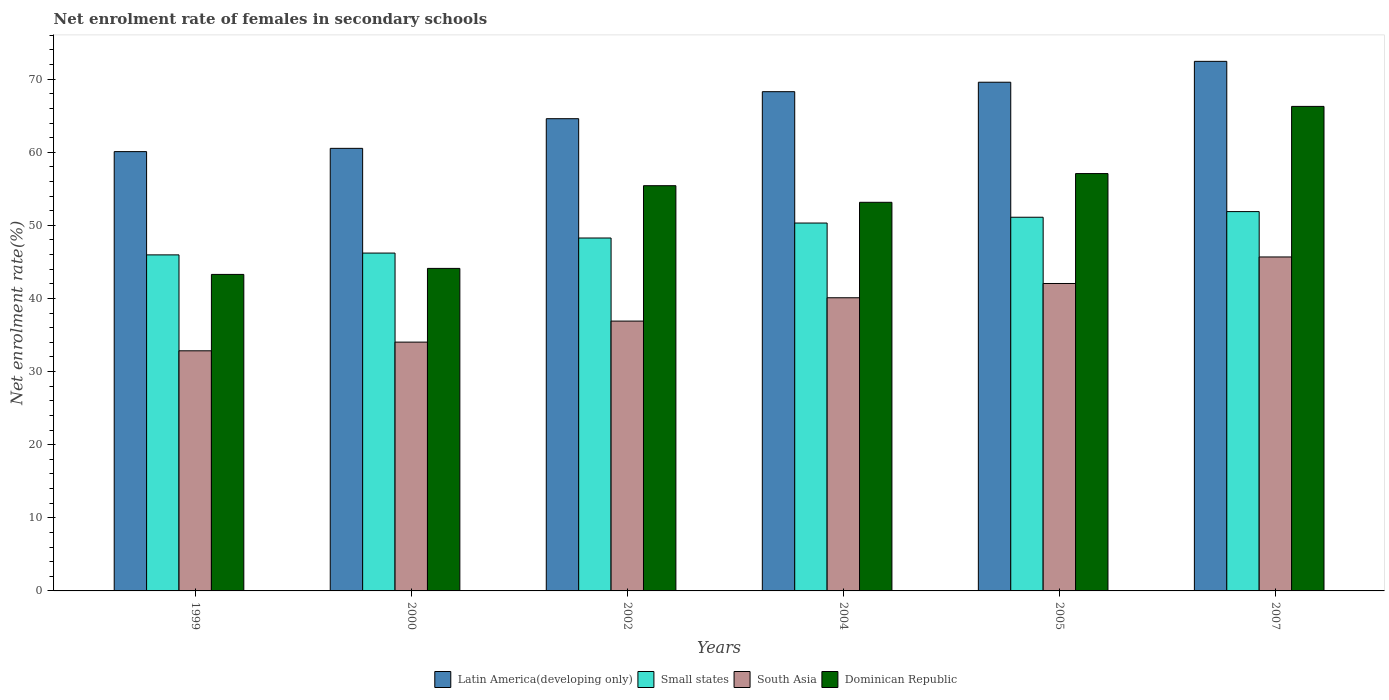Are the number of bars on each tick of the X-axis equal?
Offer a terse response. Yes. How many bars are there on the 2nd tick from the right?
Provide a succinct answer. 4. What is the net enrolment rate of females in secondary schools in Small states in 1999?
Provide a short and direct response. 45.96. Across all years, what is the maximum net enrolment rate of females in secondary schools in Latin America(developing only)?
Your response must be concise. 72.44. Across all years, what is the minimum net enrolment rate of females in secondary schools in Latin America(developing only)?
Offer a very short reply. 60.09. In which year was the net enrolment rate of females in secondary schools in Small states maximum?
Offer a terse response. 2007. What is the total net enrolment rate of females in secondary schools in Small states in the graph?
Offer a very short reply. 293.76. What is the difference between the net enrolment rate of females in secondary schools in Dominican Republic in 2000 and that in 2005?
Your answer should be very brief. -12.97. What is the difference between the net enrolment rate of females in secondary schools in Small states in 2007 and the net enrolment rate of females in secondary schools in South Asia in 2005?
Your answer should be very brief. 9.83. What is the average net enrolment rate of females in secondary schools in Dominican Republic per year?
Your answer should be very brief. 53.23. In the year 2004, what is the difference between the net enrolment rate of females in secondary schools in Dominican Republic and net enrolment rate of females in secondary schools in Latin America(developing only)?
Ensure brevity in your answer.  -15.13. What is the ratio of the net enrolment rate of females in secondary schools in South Asia in 2002 to that in 2005?
Give a very brief answer. 0.88. Is the net enrolment rate of females in secondary schools in Small states in 2004 less than that in 2007?
Ensure brevity in your answer.  Yes. Is the difference between the net enrolment rate of females in secondary schools in Dominican Republic in 1999 and 2004 greater than the difference between the net enrolment rate of females in secondary schools in Latin America(developing only) in 1999 and 2004?
Ensure brevity in your answer.  No. What is the difference between the highest and the second highest net enrolment rate of females in secondary schools in South Asia?
Provide a short and direct response. 3.63. What is the difference between the highest and the lowest net enrolment rate of females in secondary schools in South Asia?
Ensure brevity in your answer.  12.84. In how many years, is the net enrolment rate of females in secondary schools in Small states greater than the average net enrolment rate of females in secondary schools in Small states taken over all years?
Your answer should be compact. 3. Is the sum of the net enrolment rate of females in secondary schools in South Asia in 2002 and 2007 greater than the maximum net enrolment rate of females in secondary schools in Dominican Republic across all years?
Your answer should be very brief. Yes. Is it the case that in every year, the sum of the net enrolment rate of females in secondary schools in Dominican Republic and net enrolment rate of females in secondary schools in South Asia is greater than the sum of net enrolment rate of females in secondary schools in Small states and net enrolment rate of females in secondary schools in Latin America(developing only)?
Your answer should be very brief. No. What does the 4th bar from the left in 1999 represents?
Your answer should be compact. Dominican Republic. What does the 3rd bar from the right in 1999 represents?
Your answer should be compact. Small states. How many bars are there?
Ensure brevity in your answer.  24. Are all the bars in the graph horizontal?
Keep it short and to the point. No. How many years are there in the graph?
Offer a very short reply. 6. Are the values on the major ticks of Y-axis written in scientific E-notation?
Your answer should be compact. No. Does the graph contain any zero values?
Your answer should be very brief. No. Where does the legend appear in the graph?
Your answer should be very brief. Bottom center. How many legend labels are there?
Ensure brevity in your answer.  4. What is the title of the graph?
Your answer should be very brief. Net enrolment rate of females in secondary schools. Does "Slovenia" appear as one of the legend labels in the graph?
Keep it short and to the point. No. What is the label or title of the X-axis?
Offer a very short reply. Years. What is the label or title of the Y-axis?
Ensure brevity in your answer.  Net enrolment rate(%). What is the Net enrolment rate(%) of Latin America(developing only) in 1999?
Offer a very short reply. 60.09. What is the Net enrolment rate(%) of Small states in 1999?
Make the answer very short. 45.96. What is the Net enrolment rate(%) of South Asia in 1999?
Make the answer very short. 32.84. What is the Net enrolment rate(%) of Dominican Republic in 1999?
Your response must be concise. 43.29. What is the Net enrolment rate(%) of Latin America(developing only) in 2000?
Provide a short and direct response. 60.53. What is the Net enrolment rate(%) in Small states in 2000?
Offer a terse response. 46.21. What is the Net enrolment rate(%) in South Asia in 2000?
Keep it short and to the point. 34.03. What is the Net enrolment rate(%) of Dominican Republic in 2000?
Provide a short and direct response. 44.11. What is the Net enrolment rate(%) in Latin America(developing only) in 2002?
Keep it short and to the point. 64.59. What is the Net enrolment rate(%) of Small states in 2002?
Keep it short and to the point. 48.27. What is the Net enrolment rate(%) of South Asia in 2002?
Keep it short and to the point. 36.91. What is the Net enrolment rate(%) in Dominican Republic in 2002?
Offer a terse response. 55.43. What is the Net enrolment rate(%) in Latin America(developing only) in 2004?
Your answer should be very brief. 68.29. What is the Net enrolment rate(%) of Small states in 2004?
Ensure brevity in your answer.  50.32. What is the Net enrolment rate(%) in South Asia in 2004?
Ensure brevity in your answer.  40.1. What is the Net enrolment rate(%) of Dominican Republic in 2004?
Your response must be concise. 53.16. What is the Net enrolment rate(%) in Latin America(developing only) in 2005?
Make the answer very short. 69.58. What is the Net enrolment rate(%) of Small states in 2005?
Keep it short and to the point. 51.11. What is the Net enrolment rate(%) in South Asia in 2005?
Make the answer very short. 42.05. What is the Net enrolment rate(%) in Dominican Republic in 2005?
Your response must be concise. 57.09. What is the Net enrolment rate(%) of Latin America(developing only) in 2007?
Provide a short and direct response. 72.44. What is the Net enrolment rate(%) in Small states in 2007?
Your response must be concise. 51.88. What is the Net enrolment rate(%) of South Asia in 2007?
Your answer should be very brief. 45.68. What is the Net enrolment rate(%) in Dominican Republic in 2007?
Offer a terse response. 66.27. Across all years, what is the maximum Net enrolment rate(%) of Latin America(developing only)?
Provide a succinct answer. 72.44. Across all years, what is the maximum Net enrolment rate(%) in Small states?
Ensure brevity in your answer.  51.88. Across all years, what is the maximum Net enrolment rate(%) in South Asia?
Ensure brevity in your answer.  45.68. Across all years, what is the maximum Net enrolment rate(%) of Dominican Republic?
Give a very brief answer. 66.27. Across all years, what is the minimum Net enrolment rate(%) of Latin America(developing only)?
Your answer should be compact. 60.09. Across all years, what is the minimum Net enrolment rate(%) in Small states?
Provide a succinct answer. 45.96. Across all years, what is the minimum Net enrolment rate(%) in South Asia?
Ensure brevity in your answer.  32.84. Across all years, what is the minimum Net enrolment rate(%) of Dominican Republic?
Ensure brevity in your answer.  43.29. What is the total Net enrolment rate(%) of Latin America(developing only) in the graph?
Provide a succinct answer. 395.52. What is the total Net enrolment rate(%) of Small states in the graph?
Keep it short and to the point. 293.76. What is the total Net enrolment rate(%) in South Asia in the graph?
Keep it short and to the point. 231.61. What is the total Net enrolment rate(%) in Dominican Republic in the graph?
Your answer should be compact. 319.35. What is the difference between the Net enrolment rate(%) in Latin America(developing only) in 1999 and that in 2000?
Ensure brevity in your answer.  -0.45. What is the difference between the Net enrolment rate(%) of Small states in 1999 and that in 2000?
Provide a succinct answer. -0.25. What is the difference between the Net enrolment rate(%) of South Asia in 1999 and that in 2000?
Provide a succinct answer. -1.19. What is the difference between the Net enrolment rate(%) in Dominican Republic in 1999 and that in 2000?
Ensure brevity in your answer.  -0.82. What is the difference between the Net enrolment rate(%) in Latin America(developing only) in 1999 and that in 2002?
Make the answer very short. -4.5. What is the difference between the Net enrolment rate(%) of Small states in 1999 and that in 2002?
Your answer should be compact. -2.31. What is the difference between the Net enrolment rate(%) of South Asia in 1999 and that in 2002?
Ensure brevity in your answer.  -4.06. What is the difference between the Net enrolment rate(%) of Dominican Republic in 1999 and that in 2002?
Provide a short and direct response. -12.13. What is the difference between the Net enrolment rate(%) in Latin America(developing only) in 1999 and that in 2004?
Keep it short and to the point. -8.2. What is the difference between the Net enrolment rate(%) in Small states in 1999 and that in 2004?
Provide a short and direct response. -4.35. What is the difference between the Net enrolment rate(%) in South Asia in 1999 and that in 2004?
Your answer should be compact. -7.26. What is the difference between the Net enrolment rate(%) of Dominican Republic in 1999 and that in 2004?
Provide a short and direct response. -9.86. What is the difference between the Net enrolment rate(%) of Latin America(developing only) in 1999 and that in 2005?
Make the answer very short. -9.49. What is the difference between the Net enrolment rate(%) in Small states in 1999 and that in 2005?
Provide a short and direct response. -5.15. What is the difference between the Net enrolment rate(%) in South Asia in 1999 and that in 2005?
Your answer should be very brief. -9.21. What is the difference between the Net enrolment rate(%) of Dominican Republic in 1999 and that in 2005?
Your response must be concise. -13.79. What is the difference between the Net enrolment rate(%) of Latin America(developing only) in 1999 and that in 2007?
Your response must be concise. -12.35. What is the difference between the Net enrolment rate(%) in Small states in 1999 and that in 2007?
Make the answer very short. -5.92. What is the difference between the Net enrolment rate(%) of South Asia in 1999 and that in 2007?
Provide a short and direct response. -12.84. What is the difference between the Net enrolment rate(%) in Dominican Republic in 1999 and that in 2007?
Your answer should be very brief. -22.98. What is the difference between the Net enrolment rate(%) of Latin America(developing only) in 2000 and that in 2002?
Ensure brevity in your answer.  -4.06. What is the difference between the Net enrolment rate(%) of Small states in 2000 and that in 2002?
Your answer should be compact. -2.06. What is the difference between the Net enrolment rate(%) of South Asia in 2000 and that in 2002?
Your answer should be very brief. -2.88. What is the difference between the Net enrolment rate(%) of Dominican Republic in 2000 and that in 2002?
Give a very brief answer. -11.31. What is the difference between the Net enrolment rate(%) in Latin America(developing only) in 2000 and that in 2004?
Provide a succinct answer. -7.75. What is the difference between the Net enrolment rate(%) in Small states in 2000 and that in 2004?
Provide a short and direct response. -4.11. What is the difference between the Net enrolment rate(%) in South Asia in 2000 and that in 2004?
Give a very brief answer. -6.07. What is the difference between the Net enrolment rate(%) in Dominican Republic in 2000 and that in 2004?
Your response must be concise. -9.04. What is the difference between the Net enrolment rate(%) of Latin America(developing only) in 2000 and that in 2005?
Ensure brevity in your answer.  -9.05. What is the difference between the Net enrolment rate(%) of South Asia in 2000 and that in 2005?
Your answer should be compact. -8.02. What is the difference between the Net enrolment rate(%) of Dominican Republic in 2000 and that in 2005?
Your answer should be very brief. -12.97. What is the difference between the Net enrolment rate(%) of Latin America(developing only) in 2000 and that in 2007?
Ensure brevity in your answer.  -11.9. What is the difference between the Net enrolment rate(%) in Small states in 2000 and that in 2007?
Make the answer very short. -5.67. What is the difference between the Net enrolment rate(%) of South Asia in 2000 and that in 2007?
Provide a succinct answer. -11.65. What is the difference between the Net enrolment rate(%) of Dominican Republic in 2000 and that in 2007?
Keep it short and to the point. -22.16. What is the difference between the Net enrolment rate(%) of Latin America(developing only) in 2002 and that in 2004?
Provide a succinct answer. -3.7. What is the difference between the Net enrolment rate(%) of Small states in 2002 and that in 2004?
Provide a succinct answer. -2.05. What is the difference between the Net enrolment rate(%) in South Asia in 2002 and that in 2004?
Your answer should be very brief. -3.19. What is the difference between the Net enrolment rate(%) in Dominican Republic in 2002 and that in 2004?
Ensure brevity in your answer.  2.27. What is the difference between the Net enrolment rate(%) in Latin America(developing only) in 2002 and that in 2005?
Offer a very short reply. -4.99. What is the difference between the Net enrolment rate(%) in Small states in 2002 and that in 2005?
Your response must be concise. -2.84. What is the difference between the Net enrolment rate(%) in South Asia in 2002 and that in 2005?
Give a very brief answer. -5.14. What is the difference between the Net enrolment rate(%) in Dominican Republic in 2002 and that in 2005?
Your answer should be very brief. -1.66. What is the difference between the Net enrolment rate(%) of Latin America(developing only) in 2002 and that in 2007?
Ensure brevity in your answer.  -7.84. What is the difference between the Net enrolment rate(%) in Small states in 2002 and that in 2007?
Offer a terse response. -3.61. What is the difference between the Net enrolment rate(%) in South Asia in 2002 and that in 2007?
Your answer should be compact. -8.77. What is the difference between the Net enrolment rate(%) in Dominican Republic in 2002 and that in 2007?
Keep it short and to the point. -10.85. What is the difference between the Net enrolment rate(%) of Latin America(developing only) in 2004 and that in 2005?
Your answer should be very brief. -1.29. What is the difference between the Net enrolment rate(%) in Small states in 2004 and that in 2005?
Keep it short and to the point. -0.79. What is the difference between the Net enrolment rate(%) in South Asia in 2004 and that in 2005?
Ensure brevity in your answer.  -1.95. What is the difference between the Net enrolment rate(%) of Dominican Republic in 2004 and that in 2005?
Make the answer very short. -3.93. What is the difference between the Net enrolment rate(%) of Latin America(developing only) in 2004 and that in 2007?
Provide a succinct answer. -4.15. What is the difference between the Net enrolment rate(%) of Small states in 2004 and that in 2007?
Keep it short and to the point. -1.56. What is the difference between the Net enrolment rate(%) of South Asia in 2004 and that in 2007?
Offer a terse response. -5.58. What is the difference between the Net enrolment rate(%) in Dominican Republic in 2004 and that in 2007?
Ensure brevity in your answer.  -13.12. What is the difference between the Net enrolment rate(%) of Latin America(developing only) in 2005 and that in 2007?
Offer a very short reply. -2.85. What is the difference between the Net enrolment rate(%) in Small states in 2005 and that in 2007?
Provide a succinct answer. -0.77. What is the difference between the Net enrolment rate(%) of South Asia in 2005 and that in 2007?
Offer a terse response. -3.63. What is the difference between the Net enrolment rate(%) in Dominican Republic in 2005 and that in 2007?
Make the answer very short. -9.19. What is the difference between the Net enrolment rate(%) in Latin America(developing only) in 1999 and the Net enrolment rate(%) in Small states in 2000?
Your response must be concise. 13.88. What is the difference between the Net enrolment rate(%) of Latin America(developing only) in 1999 and the Net enrolment rate(%) of South Asia in 2000?
Your response must be concise. 26.06. What is the difference between the Net enrolment rate(%) in Latin America(developing only) in 1999 and the Net enrolment rate(%) in Dominican Republic in 2000?
Provide a short and direct response. 15.97. What is the difference between the Net enrolment rate(%) in Small states in 1999 and the Net enrolment rate(%) in South Asia in 2000?
Give a very brief answer. 11.93. What is the difference between the Net enrolment rate(%) in Small states in 1999 and the Net enrolment rate(%) in Dominican Republic in 2000?
Your response must be concise. 1.85. What is the difference between the Net enrolment rate(%) of South Asia in 1999 and the Net enrolment rate(%) of Dominican Republic in 2000?
Make the answer very short. -11.27. What is the difference between the Net enrolment rate(%) of Latin America(developing only) in 1999 and the Net enrolment rate(%) of Small states in 2002?
Give a very brief answer. 11.82. What is the difference between the Net enrolment rate(%) of Latin America(developing only) in 1999 and the Net enrolment rate(%) of South Asia in 2002?
Your response must be concise. 23.18. What is the difference between the Net enrolment rate(%) in Latin America(developing only) in 1999 and the Net enrolment rate(%) in Dominican Republic in 2002?
Your answer should be compact. 4.66. What is the difference between the Net enrolment rate(%) of Small states in 1999 and the Net enrolment rate(%) of South Asia in 2002?
Make the answer very short. 9.06. What is the difference between the Net enrolment rate(%) of Small states in 1999 and the Net enrolment rate(%) of Dominican Republic in 2002?
Provide a succinct answer. -9.46. What is the difference between the Net enrolment rate(%) of South Asia in 1999 and the Net enrolment rate(%) of Dominican Republic in 2002?
Make the answer very short. -22.58. What is the difference between the Net enrolment rate(%) of Latin America(developing only) in 1999 and the Net enrolment rate(%) of Small states in 2004?
Keep it short and to the point. 9.77. What is the difference between the Net enrolment rate(%) in Latin America(developing only) in 1999 and the Net enrolment rate(%) in South Asia in 2004?
Offer a terse response. 19.99. What is the difference between the Net enrolment rate(%) of Latin America(developing only) in 1999 and the Net enrolment rate(%) of Dominican Republic in 2004?
Give a very brief answer. 6.93. What is the difference between the Net enrolment rate(%) in Small states in 1999 and the Net enrolment rate(%) in South Asia in 2004?
Ensure brevity in your answer.  5.87. What is the difference between the Net enrolment rate(%) in Small states in 1999 and the Net enrolment rate(%) in Dominican Republic in 2004?
Ensure brevity in your answer.  -7.19. What is the difference between the Net enrolment rate(%) of South Asia in 1999 and the Net enrolment rate(%) of Dominican Republic in 2004?
Give a very brief answer. -20.31. What is the difference between the Net enrolment rate(%) in Latin America(developing only) in 1999 and the Net enrolment rate(%) in Small states in 2005?
Make the answer very short. 8.98. What is the difference between the Net enrolment rate(%) in Latin America(developing only) in 1999 and the Net enrolment rate(%) in South Asia in 2005?
Your answer should be very brief. 18.04. What is the difference between the Net enrolment rate(%) in Latin America(developing only) in 1999 and the Net enrolment rate(%) in Dominican Republic in 2005?
Ensure brevity in your answer.  3. What is the difference between the Net enrolment rate(%) in Small states in 1999 and the Net enrolment rate(%) in South Asia in 2005?
Offer a very short reply. 3.91. What is the difference between the Net enrolment rate(%) in Small states in 1999 and the Net enrolment rate(%) in Dominican Republic in 2005?
Ensure brevity in your answer.  -11.12. What is the difference between the Net enrolment rate(%) of South Asia in 1999 and the Net enrolment rate(%) of Dominican Republic in 2005?
Provide a succinct answer. -24.24. What is the difference between the Net enrolment rate(%) of Latin America(developing only) in 1999 and the Net enrolment rate(%) of Small states in 2007?
Provide a short and direct response. 8.2. What is the difference between the Net enrolment rate(%) of Latin America(developing only) in 1999 and the Net enrolment rate(%) of South Asia in 2007?
Offer a very short reply. 14.41. What is the difference between the Net enrolment rate(%) of Latin America(developing only) in 1999 and the Net enrolment rate(%) of Dominican Republic in 2007?
Keep it short and to the point. -6.19. What is the difference between the Net enrolment rate(%) in Small states in 1999 and the Net enrolment rate(%) in South Asia in 2007?
Your response must be concise. 0.28. What is the difference between the Net enrolment rate(%) in Small states in 1999 and the Net enrolment rate(%) in Dominican Republic in 2007?
Make the answer very short. -20.31. What is the difference between the Net enrolment rate(%) in South Asia in 1999 and the Net enrolment rate(%) in Dominican Republic in 2007?
Offer a terse response. -33.43. What is the difference between the Net enrolment rate(%) in Latin America(developing only) in 2000 and the Net enrolment rate(%) in Small states in 2002?
Your response must be concise. 12.26. What is the difference between the Net enrolment rate(%) of Latin America(developing only) in 2000 and the Net enrolment rate(%) of South Asia in 2002?
Make the answer very short. 23.63. What is the difference between the Net enrolment rate(%) of Latin America(developing only) in 2000 and the Net enrolment rate(%) of Dominican Republic in 2002?
Provide a short and direct response. 5.11. What is the difference between the Net enrolment rate(%) in Small states in 2000 and the Net enrolment rate(%) in South Asia in 2002?
Give a very brief answer. 9.3. What is the difference between the Net enrolment rate(%) of Small states in 2000 and the Net enrolment rate(%) of Dominican Republic in 2002?
Offer a very short reply. -9.22. What is the difference between the Net enrolment rate(%) in South Asia in 2000 and the Net enrolment rate(%) in Dominican Republic in 2002?
Provide a succinct answer. -21.39. What is the difference between the Net enrolment rate(%) of Latin America(developing only) in 2000 and the Net enrolment rate(%) of Small states in 2004?
Make the answer very short. 10.22. What is the difference between the Net enrolment rate(%) of Latin America(developing only) in 2000 and the Net enrolment rate(%) of South Asia in 2004?
Offer a terse response. 20.44. What is the difference between the Net enrolment rate(%) in Latin America(developing only) in 2000 and the Net enrolment rate(%) in Dominican Republic in 2004?
Ensure brevity in your answer.  7.38. What is the difference between the Net enrolment rate(%) of Small states in 2000 and the Net enrolment rate(%) of South Asia in 2004?
Provide a succinct answer. 6.11. What is the difference between the Net enrolment rate(%) in Small states in 2000 and the Net enrolment rate(%) in Dominican Republic in 2004?
Provide a short and direct response. -6.94. What is the difference between the Net enrolment rate(%) in South Asia in 2000 and the Net enrolment rate(%) in Dominican Republic in 2004?
Your response must be concise. -19.12. What is the difference between the Net enrolment rate(%) of Latin America(developing only) in 2000 and the Net enrolment rate(%) of Small states in 2005?
Offer a very short reply. 9.42. What is the difference between the Net enrolment rate(%) of Latin America(developing only) in 2000 and the Net enrolment rate(%) of South Asia in 2005?
Provide a short and direct response. 18.48. What is the difference between the Net enrolment rate(%) in Latin America(developing only) in 2000 and the Net enrolment rate(%) in Dominican Republic in 2005?
Your answer should be compact. 3.45. What is the difference between the Net enrolment rate(%) of Small states in 2000 and the Net enrolment rate(%) of South Asia in 2005?
Ensure brevity in your answer.  4.16. What is the difference between the Net enrolment rate(%) in Small states in 2000 and the Net enrolment rate(%) in Dominican Republic in 2005?
Provide a short and direct response. -10.88. What is the difference between the Net enrolment rate(%) of South Asia in 2000 and the Net enrolment rate(%) of Dominican Republic in 2005?
Provide a succinct answer. -23.05. What is the difference between the Net enrolment rate(%) of Latin America(developing only) in 2000 and the Net enrolment rate(%) of Small states in 2007?
Give a very brief answer. 8.65. What is the difference between the Net enrolment rate(%) in Latin America(developing only) in 2000 and the Net enrolment rate(%) in South Asia in 2007?
Provide a short and direct response. 14.85. What is the difference between the Net enrolment rate(%) of Latin America(developing only) in 2000 and the Net enrolment rate(%) of Dominican Republic in 2007?
Give a very brief answer. -5.74. What is the difference between the Net enrolment rate(%) of Small states in 2000 and the Net enrolment rate(%) of South Asia in 2007?
Offer a terse response. 0.53. What is the difference between the Net enrolment rate(%) of Small states in 2000 and the Net enrolment rate(%) of Dominican Republic in 2007?
Make the answer very short. -20.06. What is the difference between the Net enrolment rate(%) of South Asia in 2000 and the Net enrolment rate(%) of Dominican Republic in 2007?
Give a very brief answer. -32.24. What is the difference between the Net enrolment rate(%) of Latin America(developing only) in 2002 and the Net enrolment rate(%) of Small states in 2004?
Make the answer very short. 14.27. What is the difference between the Net enrolment rate(%) of Latin America(developing only) in 2002 and the Net enrolment rate(%) of South Asia in 2004?
Make the answer very short. 24.49. What is the difference between the Net enrolment rate(%) of Latin America(developing only) in 2002 and the Net enrolment rate(%) of Dominican Republic in 2004?
Provide a short and direct response. 11.43. What is the difference between the Net enrolment rate(%) of Small states in 2002 and the Net enrolment rate(%) of South Asia in 2004?
Provide a succinct answer. 8.17. What is the difference between the Net enrolment rate(%) in Small states in 2002 and the Net enrolment rate(%) in Dominican Republic in 2004?
Provide a short and direct response. -4.89. What is the difference between the Net enrolment rate(%) of South Asia in 2002 and the Net enrolment rate(%) of Dominican Republic in 2004?
Keep it short and to the point. -16.25. What is the difference between the Net enrolment rate(%) of Latin America(developing only) in 2002 and the Net enrolment rate(%) of Small states in 2005?
Offer a very short reply. 13.48. What is the difference between the Net enrolment rate(%) in Latin America(developing only) in 2002 and the Net enrolment rate(%) in South Asia in 2005?
Your answer should be very brief. 22.54. What is the difference between the Net enrolment rate(%) in Latin America(developing only) in 2002 and the Net enrolment rate(%) in Dominican Republic in 2005?
Make the answer very short. 7.5. What is the difference between the Net enrolment rate(%) of Small states in 2002 and the Net enrolment rate(%) of South Asia in 2005?
Your answer should be compact. 6.22. What is the difference between the Net enrolment rate(%) in Small states in 2002 and the Net enrolment rate(%) in Dominican Republic in 2005?
Your response must be concise. -8.82. What is the difference between the Net enrolment rate(%) of South Asia in 2002 and the Net enrolment rate(%) of Dominican Republic in 2005?
Your answer should be compact. -20.18. What is the difference between the Net enrolment rate(%) in Latin America(developing only) in 2002 and the Net enrolment rate(%) in Small states in 2007?
Provide a succinct answer. 12.71. What is the difference between the Net enrolment rate(%) of Latin America(developing only) in 2002 and the Net enrolment rate(%) of South Asia in 2007?
Offer a terse response. 18.91. What is the difference between the Net enrolment rate(%) in Latin America(developing only) in 2002 and the Net enrolment rate(%) in Dominican Republic in 2007?
Your response must be concise. -1.68. What is the difference between the Net enrolment rate(%) of Small states in 2002 and the Net enrolment rate(%) of South Asia in 2007?
Make the answer very short. 2.59. What is the difference between the Net enrolment rate(%) in Small states in 2002 and the Net enrolment rate(%) in Dominican Republic in 2007?
Ensure brevity in your answer.  -18. What is the difference between the Net enrolment rate(%) in South Asia in 2002 and the Net enrolment rate(%) in Dominican Republic in 2007?
Make the answer very short. -29.37. What is the difference between the Net enrolment rate(%) of Latin America(developing only) in 2004 and the Net enrolment rate(%) of Small states in 2005?
Your response must be concise. 17.18. What is the difference between the Net enrolment rate(%) in Latin America(developing only) in 2004 and the Net enrolment rate(%) in South Asia in 2005?
Your response must be concise. 26.24. What is the difference between the Net enrolment rate(%) in Latin America(developing only) in 2004 and the Net enrolment rate(%) in Dominican Republic in 2005?
Your answer should be very brief. 11.2. What is the difference between the Net enrolment rate(%) in Small states in 2004 and the Net enrolment rate(%) in South Asia in 2005?
Make the answer very short. 8.27. What is the difference between the Net enrolment rate(%) in Small states in 2004 and the Net enrolment rate(%) in Dominican Republic in 2005?
Provide a succinct answer. -6.77. What is the difference between the Net enrolment rate(%) of South Asia in 2004 and the Net enrolment rate(%) of Dominican Republic in 2005?
Keep it short and to the point. -16.99. What is the difference between the Net enrolment rate(%) in Latin America(developing only) in 2004 and the Net enrolment rate(%) in Small states in 2007?
Provide a succinct answer. 16.4. What is the difference between the Net enrolment rate(%) of Latin America(developing only) in 2004 and the Net enrolment rate(%) of South Asia in 2007?
Your answer should be very brief. 22.61. What is the difference between the Net enrolment rate(%) of Latin America(developing only) in 2004 and the Net enrolment rate(%) of Dominican Republic in 2007?
Your response must be concise. 2.01. What is the difference between the Net enrolment rate(%) in Small states in 2004 and the Net enrolment rate(%) in South Asia in 2007?
Provide a succinct answer. 4.64. What is the difference between the Net enrolment rate(%) of Small states in 2004 and the Net enrolment rate(%) of Dominican Republic in 2007?
Offer a terse response. -15.96. What is the difference between the Net enrolment rate(%) of South Asia in 2004 and the Net enrolment rate(%) of Dominican Republic in 2007?
Offer a terse response. -26.18. What is the difference between the Net enrolment rate(%) of Latin America(developing only) in 2005 and the Net enrolment rate(%) of Small states in 2007?
Provide a short and direct response. 17.7. What is the difference between the Net enrolment rate(%) in Latin America(developing only) in 2005 and the Net enrolment rate(%) in South Asia in 2007?
Your response must be concise. 23.9. What is the difference between the Net enrolment rate(%) in Latin America(developing only) in 2005 and the Net enrolment rate(%) in Dominican Republic in 2007?
Give a very brief answer. 3.31. What is the difference between the Net enrolment rate(%) of Small states in 2005 and the Net enrolment rate(%) of South Asia in 2007?
Your response must be concise. 5.43. What is the difference between the Net enrolment rate(%) of Small states in 2005 and the Net enrolment rate(%) of Dominican Republic in 2007?
Make the answer very short. -15.16. What is the difference between the Net enrolment rate(%) in South Asia in 2005 and the Net enrolment rate(%) in Dominican Republic in 2007?
Offer a very short reply. -24.22. What is the average Net enrolment rate(%) in Latin America(developing only) per year?
Your answer should be very brief. 65.92. What is the average Net enrolment rate(%) of Small states per year?
Your answer should be very brief. 48.96. What is the average Net enrolment rate(%) of South Asia per year?
Ensure brevity in your answer.  38.6. What is the average Net enrolment rate(%) in Dominican Republic per year?
Provide a succinct answer. 53.23. In the year 1999, what is the difference between the Net enrolment rate(%) of Latin America(developing only) and Net enrolment rate(%) of Small states?
Your answer should be very brief. 14.12. In the year 1999, what is the difference between the Net enrolment rate(%) in Latin America(developing only) and Net enrolment rate(%) in South Asia?
Your answer should be compact. 27.24. In the year 1999, what is the difference between the Net enrolment rate(%) in Latin America(developing only) and Net enrolment rate(%) in Dominican Republic?
Your answer should be very brief. 16.8. In the year 1999, what is the difference between the Net enrolment rate(%) of Small states and Net enrolment rate(%) of South Asia?
Keep it short and to the point. 13.12. In the year 1999, what is the difference between the Net enrolment rate(%) in Small states and Net enrolment rate(%) in Dominican Republic?
Offer a terse response. 2.67. In the year 1999, what is the difference between the Net enrolment rate(%) of South Asia and Net enrolment rate(%) of Dominican Republic?
Keep it short and to the point. -10.45. In the year 2000, what is the difference between the Net enrolment rate(%) in Latin America(developing only) and Net enrolment rate(%) in Small states?
Provide a short and direct response. 14.32. In the year 2000, what is the difference between the Net enrolment rate(%) in Latin America(developing only) and Net enrolment rate(%) in South Asia?
Give a very brief answer. 26.5. In the year 2000, what is the difference between the Net enrolment rate(%) in Latin America(developing only) and Net enrolment rate(%) in Dominican Republic?
Give a very brief answer. 16.42. In the year 2000, what is the difference between the Net enrolment rate(%) in Small states and Net enrolment rate(%) in South Asia?
Provide a short and direct response. 12.18. In the year 2000, what is the difference between the Net enrolment rate(%) in Small states and Net enrolment rate(%) in Dominican Republic?
Offer a terse response. 2.1. In the year 2000, what is the difference between the Net enrolment rate(%) of South Asia and Net enrolment rate(%) of Dominican Republic?
Make the answer very short. -10.08. In the year 2002, what is the difference between the Net enrolment rate(%) of Latin America(developing only) and Net enrolment rate(%) of Small states?
Make the answer very short. 16.32. In the year 2002, what is the difference between the Net enrolment rate(%) in Latin America(developing only) and Net enrolment rate(%) in South Asia?
Provide a short and direct response. 27.68. In the year 2002, what is the difference between the Net enrolment rate(%) in Latin America(developing only) and Net enrolment rate(%) in Dominican Republic?
Give a very brief answer. 9.16. In the year 2002, what is the difference between the Net enrolment rate(%) of Small states and Net enrolment rate(%) of South Asia?
Provide a short and direct response. 11.36. In the year 2002, what is the difference between the Net enrolment rate(%) of Small states and Net enrolment rate(%) of Dominican Republic?
Keep it short and to the point. -7.16. In the year 2002, what is the difference between the Net enrolment rate(%) in South Asia and Net enrolment rate(%) in Dominican Republic?
Offer a very short reply. -18.52. In the year 2004, what is the difference between the Net enrolment rate(%) of Latin America(developing only) and Net enrolment rate(%) of Small states?
Ensure brevity in your answer.  17.97. In the year 2004, what is the difference between the Net enrolment rate(%) of Latin America(developing only) and Net enrolment rate(%) of South Asia?
Your response must be concise. 28.19. In the year 2004, what is the difference between the Net enrolment rate(%) in Latin America(developing only) and Net enrolment rate(%) in Dominican Republic?
Your answer should be very brief. 15.13. In the year 2004, what is the difference between the Net enrolment rate(%) of Small states and Net enrolment rate(%) of South Asia?
Your response must be concise. 10.22. In the year 2004, what is the difference between the Net enrolment rate(%) of Small states and Net enrolment rate(%) of Dominican Republic?
Your answer should be compact. -2.84. In the year 2004, what is the difference between the Net enrolment rate(%) of South Asia and Net enrolment rate(%) of Dominican Republic?
Your response must be concise. -13.06. In the year 2005, what is the difference between the Net enrolment rate(%) in Latin America(developing only) and Net enrolment rate(%) in Small states?
Give a very brief answer. 18.47. In the year 2005, what is the difference between the Net enrolment rate(%) of Latin America(developing only) and Net enrolment rate(%) of South Asia?
Your answer should be very brief. 27.53. In the year 2005, what is the difference between the Net enrolment rate(%) in Latin America(developing only) and Net enrolment rate(%) in Dominican Republic?
Make the answer very short. 12.49. In the year 2005, what is the difference between the Net enrolment rate(%) in Small states and Net enrolment rate(%) in South Asia?
Keep it short and to the point. 9.06. In the year 2005, what is the difference between the Net enrolment rate(%) of Small states and Net enrolment rate(%) of Dominican Republic?
Your response must be concise. -5.98. In the year 2005, what is the difference between the Net enrolment rate(%) of South Asia and Net enrolment rate(%) of Dominican Republic?
Provide a short and direct response. -15.04. In the year 2007, what is the difference between the Net enrolment rate(%) of Latin America(developing only) and Net enrolment rate(%) of Small states?
Your answer should be very brief. 20.55. In the year 2007, what is the difference between the Net enrolment rate(%) in Latin America(developing only) and Net enrolment rate(%) in South Asia?
Provide a short and direct response. 26.76. In the year 2007, what is the difference between the Net enrolment rate(%) in Latin America(developing only) and Net enrolment rate(%) in Dominican Republic?
Make the answer very short. 6.16. In the year 2007, what is the difference between the Net enrolment rate(%) of Small states and Net enrolment rate(%) of South Asia?
Your response must be concise. 6.2. In the year 2007, what is the difference between the Net enrolment rate(%) of Small states and Net enrolment rate(%) of Dominican Republic?
Offer a very short reply. -14.39. In the year 2007, what is the difference between the Net enrolment rate(%) in South Asia and Net enrolment rate(%) in Dominican Republic?
Your answer should be compact. -20.59. What is the ratio of the Net enrolment rate(%) in Latin America(developing only) in 1999 to that in 2000?
Provide a succinct answer. 0.99. What is the ratio of the Net enrolment rate(%) in South Asia in 1999 to that in 2000?
Provide a succinct answer. 0.97. What is the ratio of the Net enrolment rate(%) of Dominican Republic in 1999 to that in 2000?
Offer a terse response. 0.98. What is the ratio of the Net enrolment rate(%) in Latin America(developing only) in 1999 to that in 2002?
Offer a terse response. 0.93. What is the ratio of the Net enrolment rate(%) in Small states in 1999 to that in 2002?
Keep it short and to the point. 0.95. What is the ratio of the Net enrolment rate(%) of South Asia in 1999 to that in 2002?
Offer a very short reply. 0.89. What is the ratio of the Net enrolment rate(%) of Dominican Republic in 1999 to that in 2002?
Your answer should be very brief. 0.78. What is the ratio of the Net enrolment rate(%) in Latin America(developing only) in 1999 to that in 2004?
Your response must be concise. 0.88. What is the ratio of the Net enrolment rate(%) of Small states in 1999 to that in 2004?
Your answer should be compact. 0.91. What is the ratio of the Net enrolment rate(%) in South Asia in 1999 to that in 2004?
Provide a short and direct response. 0.82. What is the ratio of the Net enrolment rate(%) of Dominican Republic in 1999 to that in 2004?
Ensure brevity in your answer.  0.81. What is the ratio of the Net enrolment rate(%) in Latin America(developing only) in 1999 to that in 2005?
Provide a short and direct response. 0.86. What is the ratio of the Net enrolment rate(%) of Small states in 1999 to that in 2005?
Your response must be concise. 0.9. What is the ratio of the Net enrolment rate(%) of South Asia in 1999 to that in 2005?
Keep it short and to the point. 0.78. What is the ratio of the Net enrolment rate(%) in Dominican Republic in 1999 to that in 2005?
Offer a very short reply. 0.76. What is the ratio of the Net enrolment rate(%) of Latin America(developing only) in 1999 to that in 2007?
Ensure brevity in your answer.  0.83. What is the ratio of the Net enrolment rate(%) of Small states in 1999 to that in 2007?
Your answer should be very brief. 0.89. What is the ratio of the Net enrolment rate(%) of South Asia in 1999 to that in 2007?
Provide a short and direct response. 0.72. What is the ratio of the Net enrolment rate(%) in Dominican Republic in 1999 to that in 2007?
Offer a very short reply. 0.65. What is the ratio of the Net enrolment rate(%) of Latin America(developing only) in 2000 to that in 2002?
Offer a very short reply. 0.94. What is the ratio of the Net enrolment rate(%) of Small states in 2000 to that in 2002?
Provide a short and direct response. 0.96. What is the ratio of the Net enrolment rate(%) in South Asia in 2000 to that in 2002?
Your answer should be very brief. 0.92. What is the ratio of the Net enrolment rate(%) of Dominican Republic in 2000 to that in 2002?
Make the answer very short. 0.8. What is the ratio of the Net enrolment rate(%) of Latin America(developing only) in 2000 to that in 2004?
Offer a terse response. 0.89. What is the ratio of the Net enrolment rate(%) of Small states in 2000 to that in 2004?
Make the answer very short. 0.92. What is the ratio of the Net enrolment rate(%) in South Asia in 2000 to that in 2004?
Provide a short and direct response. 0.85. What is the ratio of the Net enrolment rate(%) in Dominican Republic in 2000 to that in 2004?
Your answer should be compact. 0.83. What is the ratio of the Net enrolment rate(%) in Latin America(developing only) in 2000 to that in 2005?
Provide a short and direct response. 0.87. What is the ratio of the Net enrolment rate(%) of Small states in 2000 to that in 2005?
Keep it short and to the point. 0.9. What is the ratio of the Net enrolment rate(%) in South Asia in 2000 to that in 2005?
Provide a succinct answer. 0.81. What is the ratio of the Net enrolment rate(%) in Dominican Republic in 2000 to that in 2005?
Your answer should be very brief. 0.77. What is the ratio of the Net enrolment rate(%) in Latin America(developing only) in 2000 to that in 2007?
Your answer should be very brief. 0.84. What is the ratio of the Net enrolment rate(%) of Small states in 2000 to that in 2007?
Your response must be concise. 0.89. What is the ratio of the Net enrolment rate(%) of South Asia in 2000 to that in 2007?
Provide a succinct answer. 0.74. What is the ratio of the Net enrolment rate(%) of Dominican Republic in 2000 to that in 2007?
Your answer should be compact. 0.67. What is the ratio of the Net enrolment rate(%) in Latin America(developing only) in 2002 to that in 2004?
Offer a terse response. 0.95. What is the ratio of the Net enrolment rate(%) of Small states in 2002 to that in 2004?
Provide a succinct answer. 0.96. What is the ratio of the Net enrolment rate(%) in South Asia in 2002 to that in 2004?
Provide a succinct answer. 0.92. What is the ratio of the Net enrolment rate(%) of Dominican Republic in 2002 to that in 2004?
Your response must be concise. 1.04. What is the ratio of the Net enrolment rate(%) of Latin America(developing only) in 2002 to that in 2005?
Your response must be concise. 0.93. What is the ratio of the Net enrolment rate(%) of Small states in 2002 to that in 2005?
Give a very brief answer. 0.94. What is the ratio of the Net enrolment rate(%) in South Asia in 2002 to that in 2005?
Offer a very short reply. 0.88. What is the ratio of the Net enrolment rate(%) in Dominican Republic in 2002 to that in 2005?
Ensure brevity in your answer.  0.97. What is the ratio of the Net enrolment rate(%) of Latin America(developing only) in 2002 to that in 2007?
Provide a short and direct response. 0.89. What is the ratio of the Net enrolment rate(%) in Small states in 2002 to that in 2007?
Give a very brief answer. 0.93. What is the ratio of the Net enrolment rate(%) of South Asia in 2002 to that in 2007?
Your response must be concise. 0.81. What is the ratio of the Net enrolment rate(%) in Dominican Republic in 2002 to that in 2007?
Your response must be concise. 0.84. What is the ratio of the Net enrolment rate(%) of Latin America(developing only) in 2004 to that in 2005?
Your answer should be compact. 0.98. What is the ratio of the Net enrolment rate(%) of Small states in 2004 to that in 2005?
Your response must be concise. 0.98. What is the ratio of the Net enrolment rate(%) in South Asia in 2004 to that in 2005?
Your answer should be very brief. 0.95. What is the ratio of the Net enrolment rate(%) in Dominican Republic in 2004 to that in 2005?
Offer a terse response. 0.93. What is the ratio of the Net enrolment rate(%) in Latin America(developing only) in 2004 to that in 2007?
Provide a succinct answer. 0.94. What is the ratio of the Net enrolment rate(%) in Small states in 2004 to that in 2007?
Your answer should be compact. 0.97. What is the ratio of the Net enrolment rate(%) in South Asia in 2004 to that in 2007?
Your response must be concise. 0.88. What is the ratio of the Net enrolment rate(%) of Dominican Republic in 2004 to that in 2007?
Offer a terse response. 0.8. What is the ratio of the Net enrolment rate(%) in Latin America(developing only) in 2005 to that in 2007?
Provide a short and direct response. 0.96. What is the ratio of the Net enrolment rate(%) of Small states in 2005 to that in 2007?
Give a very brief answer. 0.99. What is the ratio of the Net enrolment rate(%) in South Asia in 2005 to that in 2007?
Make the answer very short. 0.92. What is the ratio of the Net enrolment rate(%) in Dominican Republic in 2005 to that in 2007?
Keep it short and to the point. 0.86. What is the difference between the highest and the second highest Net enrolment rate(%) in Latin America(developing only)?
Offer a very short reply. 2.85. What is the difference between the highest and the second highest Net enrolment rate(%) in Small states?
Your answer should be compact. 0.77. What is the difference between the highest and the second highest Net enrolment rate(%) of South Asia?
Give a very brief answer. 3.63. What is the difference between the highest and the second highest Net enrolment rate(%) in Dominican Republic?
Your answer should be very brief. 9.19. What is the difference between the highest and the lowest Net enrolment rate(%) of Latin America(developing only)?
Your response must be concise. 12.35. What is the difference between the highest and the lowest Net enrolment rate(%) of Small states?
Ensure brevity in your answer.  5.92. What is the difference between the highest and the lowest Net enrolment rate(%) of South Asia?
Your response must be concise. 12.84. What is the difference between the highest and the lowest Net enrolment rate(%) in Dominican Republic?
Ensure brevity in your answer.  22.98. 